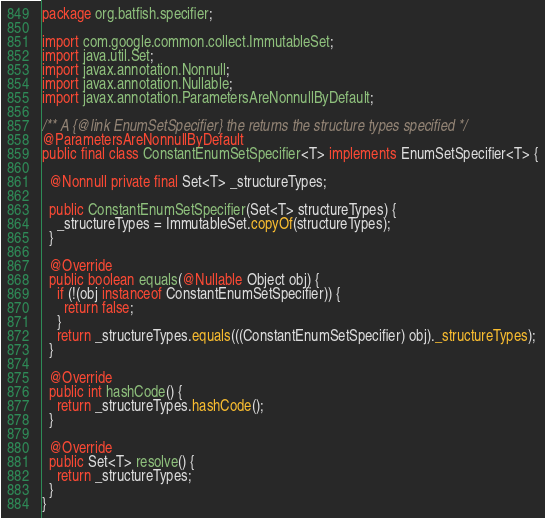<code> <loc_0><loc_0><loc_500><loc_500><_Java_>package org.batfish.specifier;

import com.google.common.collect.ImmutableSet;
import java.util.Set;
import javax.annotation.Nonnull;
import javax.annotation.Nullable;
import javax.annotation.ParametersAreNonnullByDefault;

/** A {@link EnumSetSpecifier} the returns the structure types specified */
@ParametersAreNonnullByDefault
public final class ConstantEnumSetSpecifier<T> implements EnumSetSpecifier<T> {

  @Nonnull private final Set<T> _structureTypes;

  public ConstantEnumSetSpecifier(Set<T> structureTypes) {
    _structureTypes = ImmutableSet.copyOf(structureTypes);
  }

  @Override
  public boolean equals(@Nullable Object obj) {
    if (!(obj instanceof ConstantEnumSetSpecifier)) {
      return false;
    }
    return _structureTypes.equals(((ConstantEnumSetSpecifier) obj)._structureTypes);
  }

  @Override
  public int hashCode() {
    return _structureTypes.hashCode();
  }

  @Override
  public Set<T> resolve() {
    return _structureTypes;
  }
}
</code> 